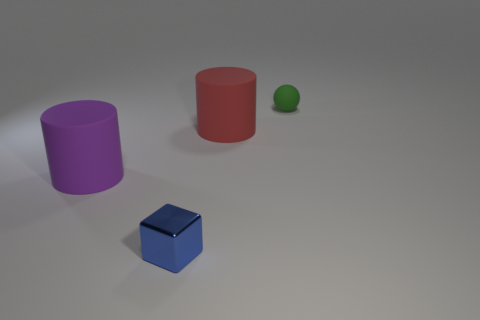How many objects are either big things or red matte things?
Your answer should be very brief. 2. Is the cylinder left of the tiny blue metallic object made of the same material as the large red cylinder?
Your answer should be compact. Yes. How many things are tiny things right of the blue metal thing or purple objects?
Make the answer very short. 2. There is a small ball that is made of the same material as the big red object; what color is it?
Provide a succinct answer. Green. Is there a red shiny cylinder of the same size as the red thing?
Your answer should be very brief. No. There is a large object that is behind the large purple cylinder; is its color the same as the rubber sphere?
Provide a short and direct response. No. What color is the object that is on the right side of the big purple rubber cylinder and on the left side of the big red cylinder?
Offer a terse response. Blue. What shape is the green thing that is the same size as the blue metal cube?
Offer a very short reply. Sphere. Is there another matte object that has the same shape as the large red thing?
Offer a terse response. Yes. Does the rubber thing that is behind the red object have the same size as the purple matte cylinder?
Provide a succinct answer. No. 